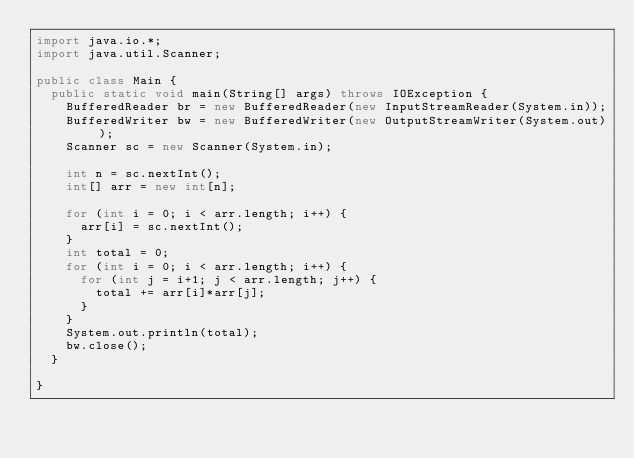<code> <loc_0><loc_0><loc_500><loc_500><_Java_>import java.io.*;
import java.util.Scanner;

public class Main {
	public static void main(String[] args) throws IOException {
		BufferedReader br = new BufferedReader(new InputStreamReader(System.in));
		BufferedWriter bw = new BufferedWriter(new OutputStreamWriter(System.out));
		Scanner sc = new Scanner(System.in);
		
		int n = sc.nextInt();
		int[] arr = new int[n];
		
		for (int i = 0; i < arr.length; i++) {
			arr[i] = sc.nextInt();
		}
		int total = 0;
		for (int i = 0; i < arr.length; i++) {
			for (int j = i+1; j < arr.length; j++) {
				total += arr[i]*arr[j];
			}
		}
		System.out.println(total);
		bw.close();
	}

}
</code> 